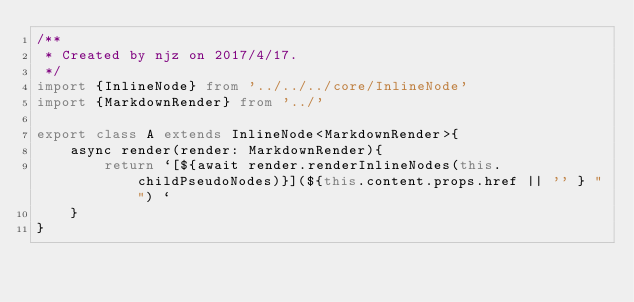Convert code to text. <code><loc_0><loc_0><loc_500><loc_500><_TypeScript_>/**
 * Created by njz on 2017/4/17.
 */
import {InlineNode} from '../../../core/InlineNode'
import {MarkdownRender} from '../'

export class A extends InlineNode<MarkdownRender>{
    async render(render: MarkdownRender){
        return `[${await render.renderInlineNodes(this.childPseudoNodes)}](${this.content.props.href || '' } "") `
    }
}
</code> 